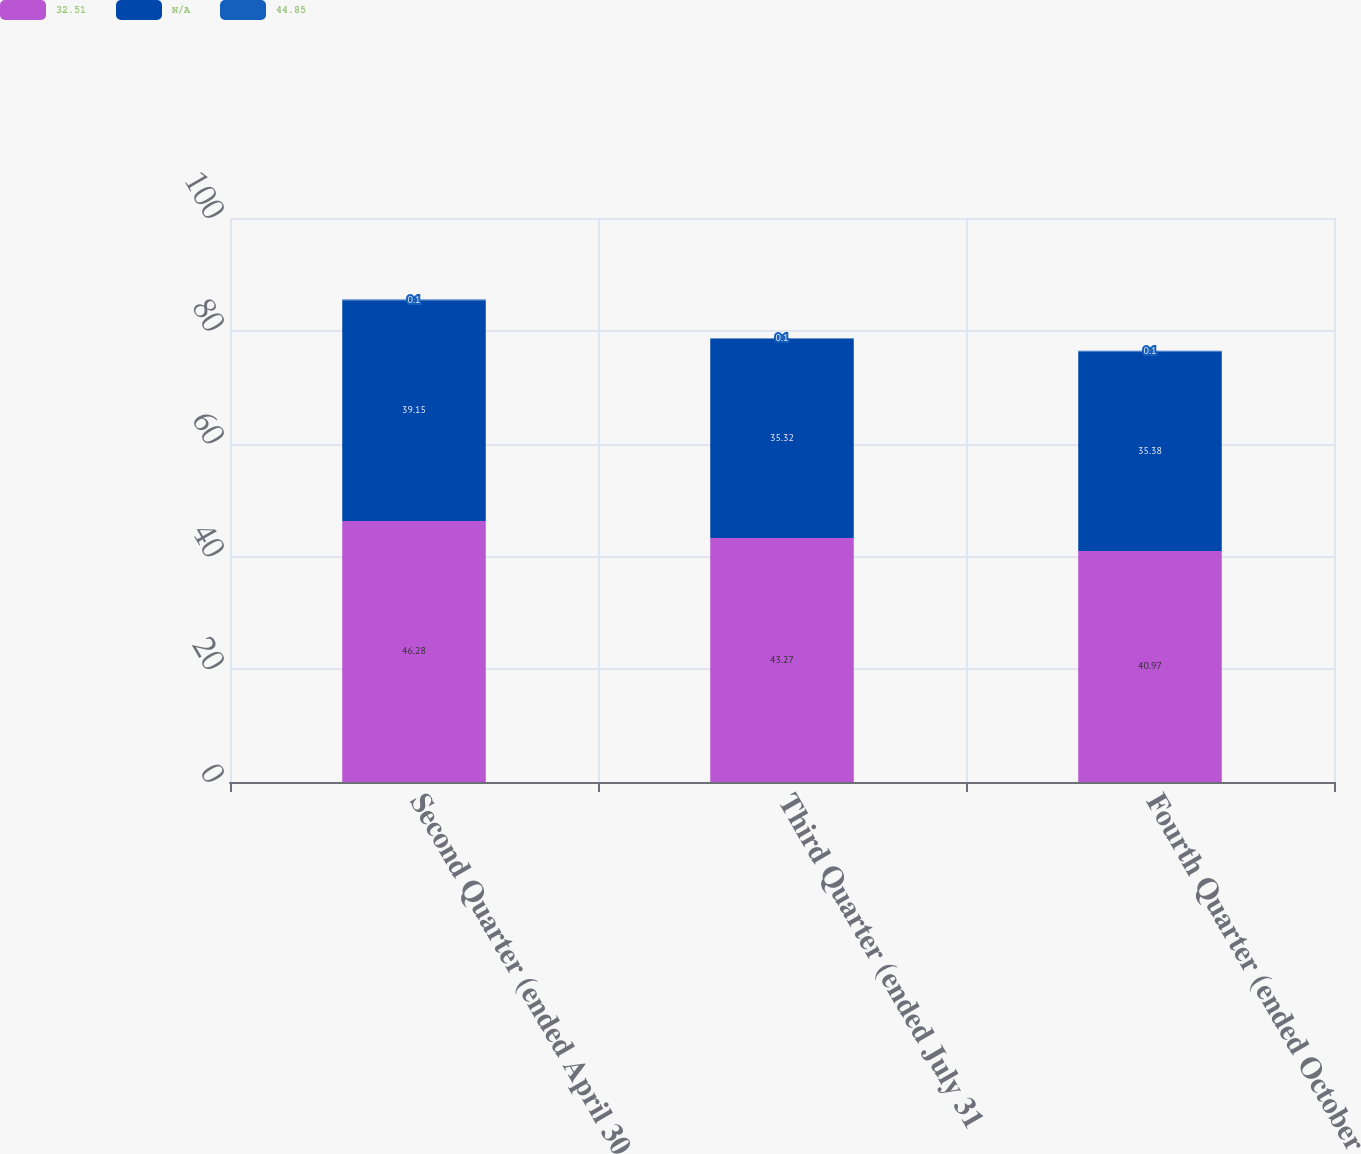<chart> <loc_0><loc_0><loc_500><loc_500><stacked_bar_chart><ecel><fcel>Second Quarter (ended April 30<fcel>Third Quarter (ended July 31<fcel>Fourth Quarter (ended October<nl><fcel>32.51<fcel>46.28<fcel>43.27<fcel>40.97<nl><fcel>nan<fcel>39.15<fcel>35.32<fcel>35.38<nl><fcel>44.85<fcel>0.1<fcel>0.1<fcel>0.1<nl></chart> 